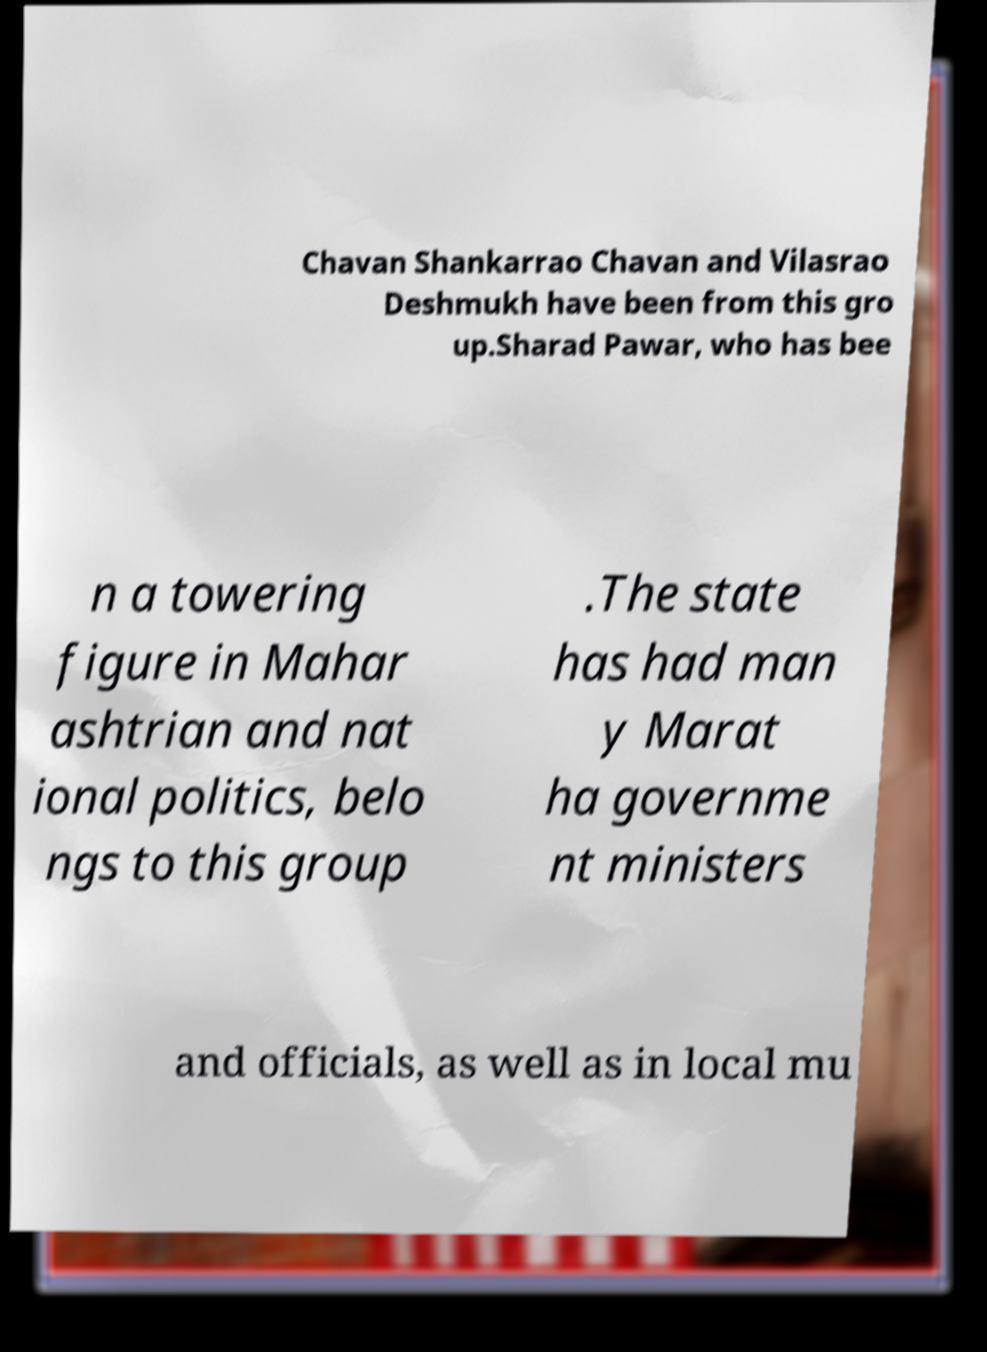There's text embedded in this image that I need extracted. Can you transcribe it verbatim? Chavan Shankarrao Chavan and Vilasrao Deshmukh have been from this gro up.Sharad Pawar, who has bee n a towering figure in Mahar ashtrian and nat ional politics, belo ngs to this group .The state has had man y Marat ha governme nt ministers and officials, as well as in local mu 